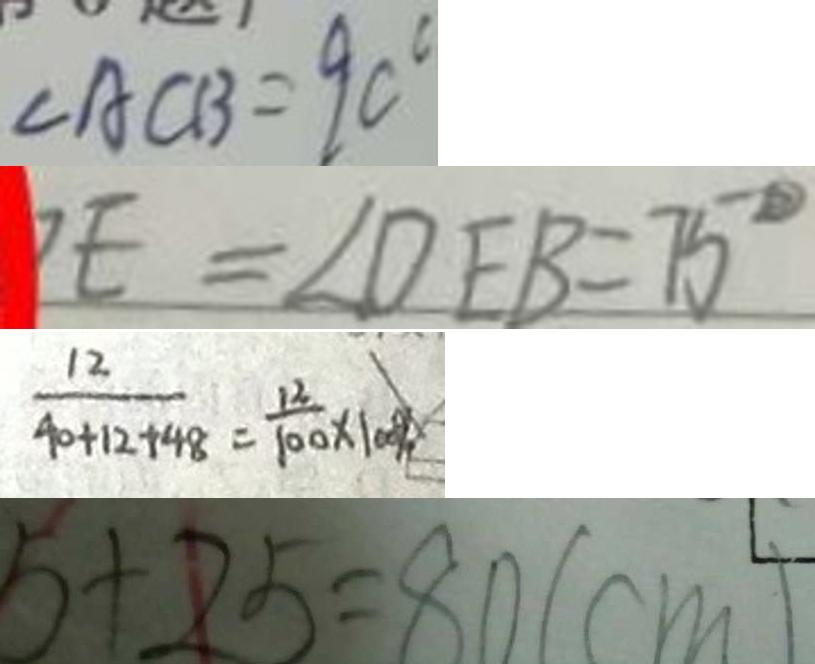<formula> <loc_0><loc_0><loc_500><loc_500>\angle A C B = 9 0 ^ { \circ } 
 E = \angle D E B = 7 5 ^ { \circ } 
 \frac { 1 2 } { 4 0 + 1 2 + 4 8 } = \frac { 1 2 } { 1 0 0 } \times 1 0 0 \% 
 5 + 2 5 = 8 0 ( c m )</formula> 